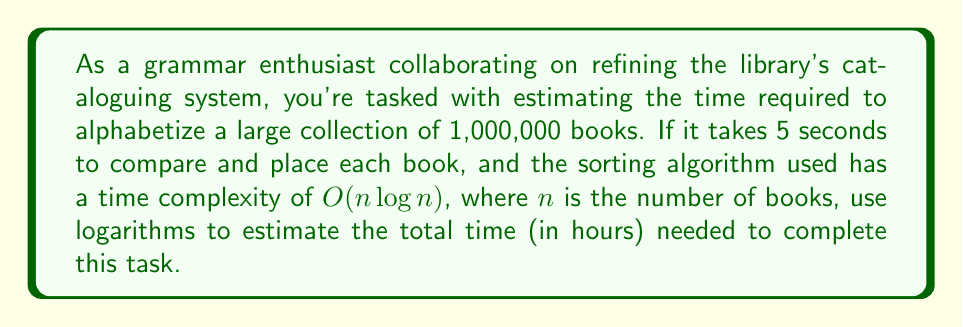Can you solve this math problem? Let's approach this step-by-step:

1) The time complexity of the sorting algorithm is $O(n \log n)$, where $n = 1,000,000$.

2) We need to calculate $n \log n$:
   $$1,000,000 \cdot \log_{10}(1,000,000)$$

3) $\log_{10}(1,000,000) = \log_{10}(10^6) = 6$

4) So, we have:
   $$1,000,000 \cdot 6 = 6,000,000$$

5) This means we need to perform approximately 6,000,000 comparisons.

6) Each comparison takes 5 seconds, so the total time in seconds is:
   $$6,000,000 \cdot 5 = 30,000,000 \text{ seconds}$$

7) To convert this to hours, we divide by 3600 (the number of seconds in an hour):
   $$\frac{30,000,000}{3600} = 8,333.33 \text{ hours}$$

8) Rounding to the nearest hour, we get 8,333 hours.
Answer: 8,333 hours 